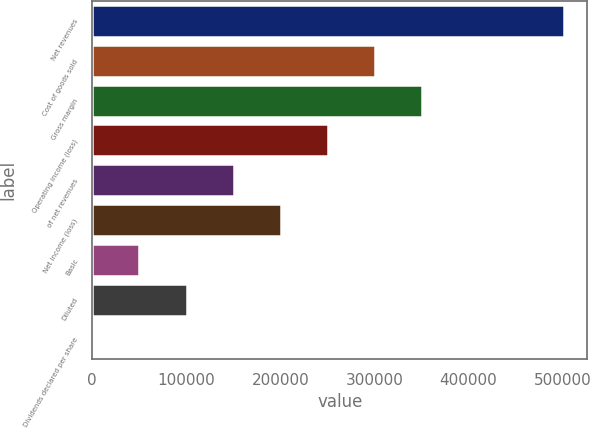<chart> <loc_0><loc_0><loc_500><loc_500><bar_chart><fcel>Net revenues<fcel>Cost of goods sold<fcel>Gross margin<fcel>Operating income (loss)<fcel>of net revenues<fcel>Net income (loss)<fcel>Basic<fcel>Diluted<fcel>Dividends declared per share<nl><fcel>501204<fcel>300722<fcel>350843<fcel>250602<fcel>150361<fcel>200482<fcel>50120.6<fcel>100241<fcel>0.2<nl></chart> 